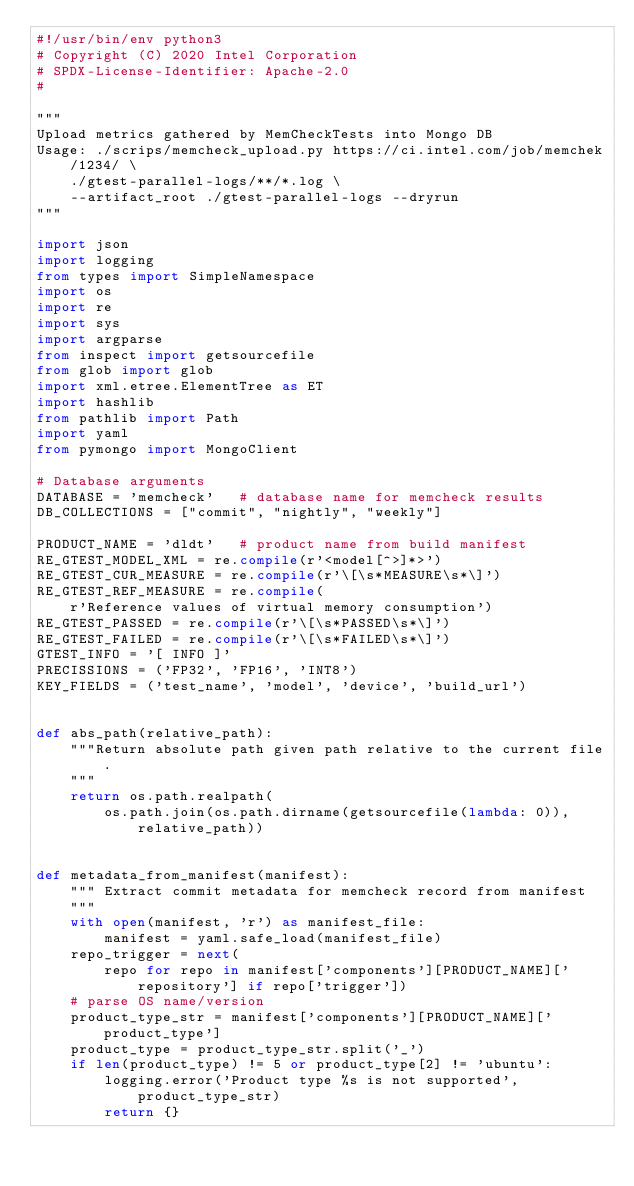<code> <loc_0><loc_0><loc_500><loc_500><_Python_>#!/usr/bin/env python3
# Copyright (C) 2020 Intel Corporation
# SPDX-License-Identifier: Apache-2.0
#

"""
Upload metrics gathered by MemCheckTests into Mongo DB
Usage: ./scrips/memcheck_upload.py https://ci.intel.com/job/memchek/1234/ \
    ./gtest-parallel-logs/**/*.log \
    --artifact_root ./gtest-parallel-logs --dryrun
"""

import json
import logging
from types import SimpleNamespace
import os
import re
import sys
import argparse
from inspect import getsourcefile
from glob import glob
import xml.etree.ElementTree as ET
import hashlib
from pathlib import Path
import yaml
from pymongo import MongoClient

# Database arguments
DATABASE = 'memcheck'   # database name for memcheck results
DB_COLLECTIONS = ["commit", "nightly", "weekly"]

PRODUCT_NAME = 'dldt'   # product name from build manifest
RE_GTEST_MODEL_XML = re.compile(r'<model[^>]*>')
RE_GTEST_CUR_MEASURE = re.compile(r'\[\s*MEASURE\s*\]')
RE_GTEST_REF_MEASURE = re.compile(
    r'Reference values of virtual memory consumption')
RE_GTEST_PASSED = re.compile(r'\[\s*PASSED\s*\]')
RE_GTEST_FAILED = re.compile(r'\[\s*FAILED\s*\]')
GTEST_INFO = '[ INFO ]'
PRECISSIONS = ('FP32', 'FP16', 'INT8')
KEY_FIELDS = ('test_name', 'model', 'device', 'build_url')


def abs_path(relative_path):
    """Return absolute path given path relative to the current file.
    """
    return os.path.realpath(
        os.path.join(os.path.dirname(getsourcefile(lambda: 0)), relative_path))


def metadata_from_manifest(manifest):
    """ Extract commit metadata for memcheck record from manifest
    """
    with open(manifest, 'r') as manifest_file:
        manifest = yaml.safe_load(manifest_file)
    repo_trigger = next(
        repo for repo in manifest['components'][PRODUCT_NAME]['repository'] if repo['trigger'])
    # parse OS name/version
    product_type_str = manifest['components'][PRODUCT_NAME]['product_type']
    product_type = product_type_str.split('_')
    if len(product_type) != 5 or product_type[2] != 'ubuntu':
        logging.error('Product type %s is not supported', product_type_str)
        return {}</code> 